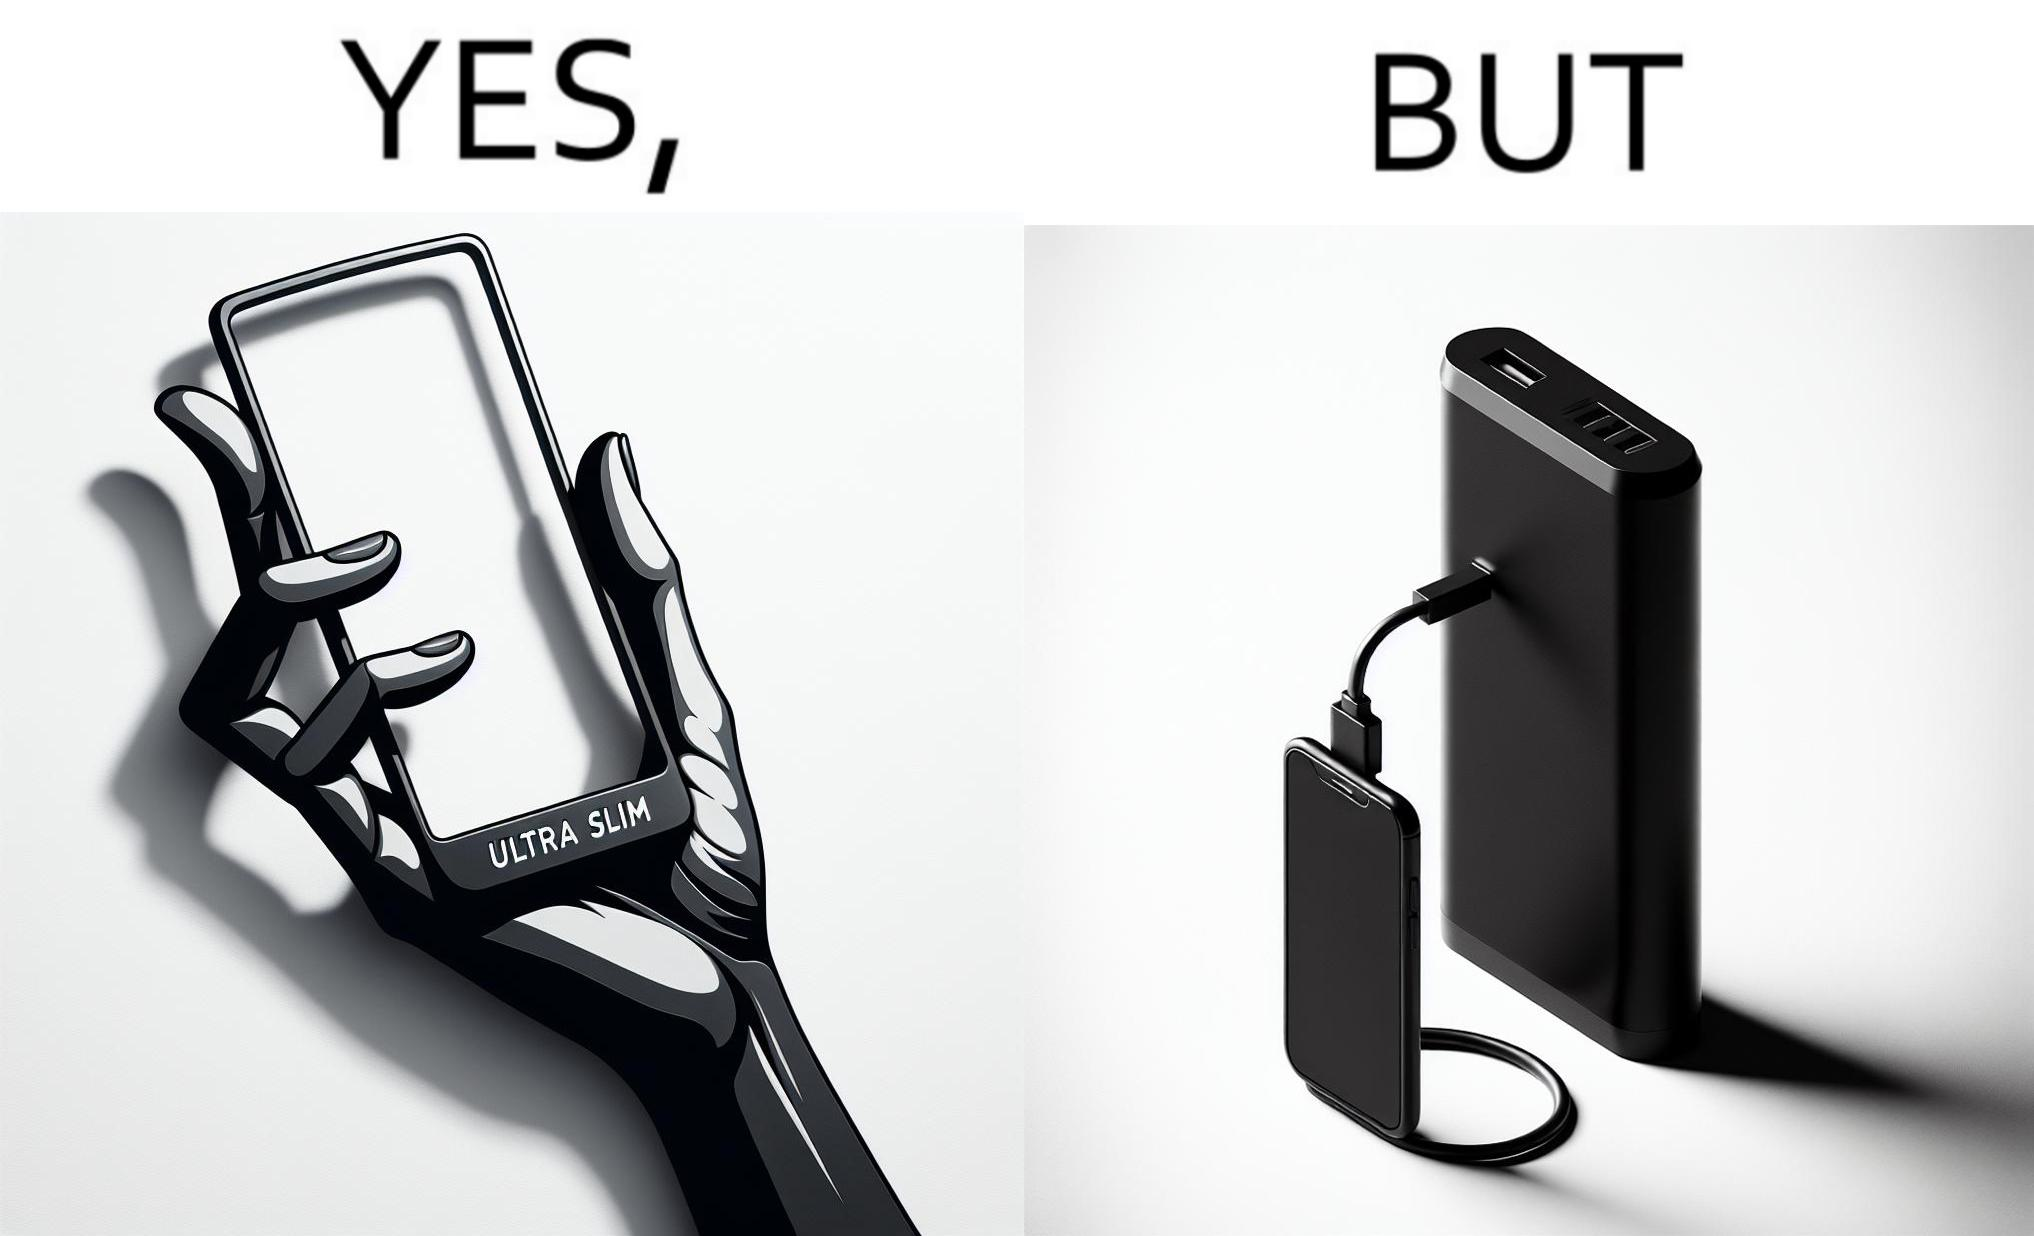Would you classify this image as satirical? Yes, this image is satirical. 